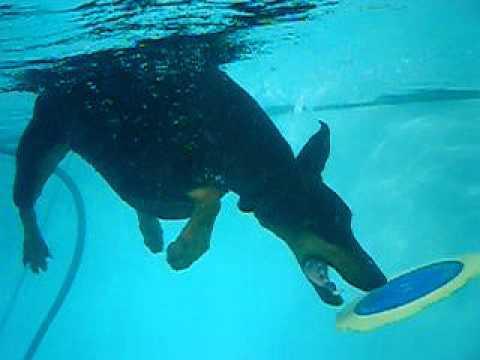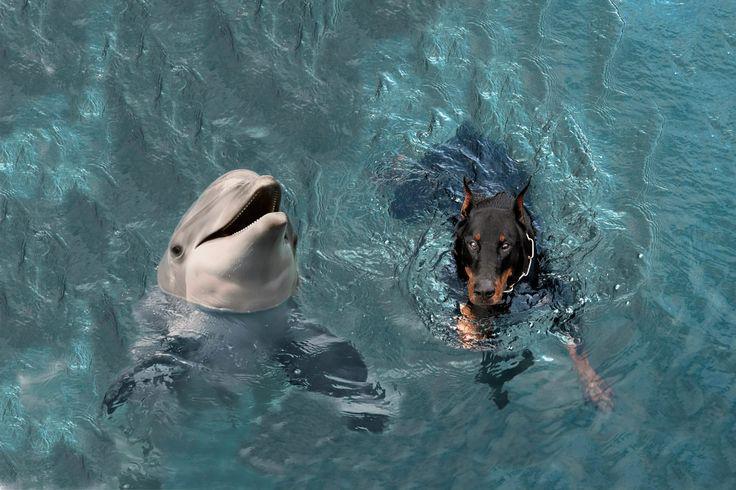The first image is the image on the left, the second image is the image on the right. Evaluate the accuracy of this statement regarding the images: "An image shows a doberman underwater with his muzzle pointed downward just above a flat object.". Is it true? Answer yes or no. Yes. The first image is the image on the left, the second image is the image on the right. Assess this claim about the two images: "The left and right image contains the same number of dogs with at least one dog grabbing a frisbee.". Correct or not? Answer yes or no. Yes. 